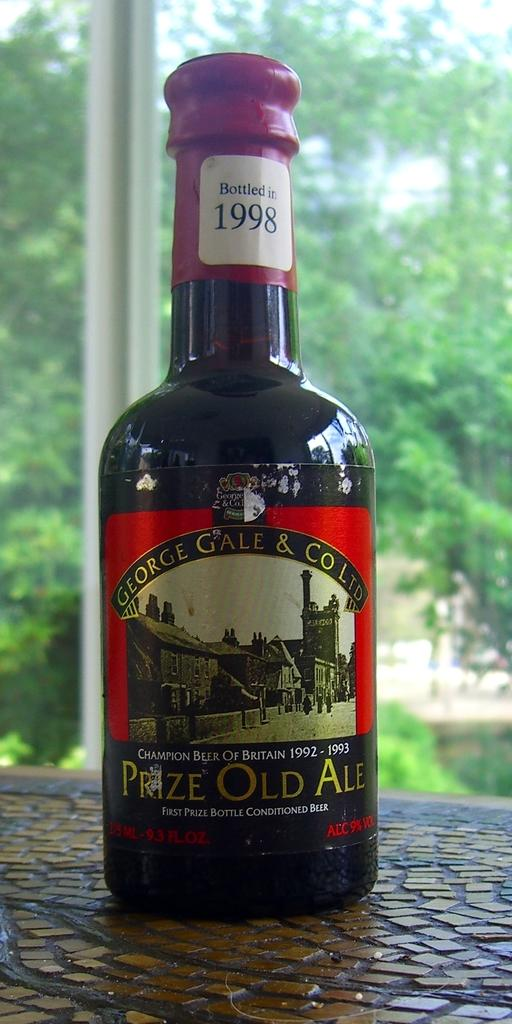<image>
Describe the image concisely. Bottle of 1998 George Gale Ltd, made Prize Old Ale 